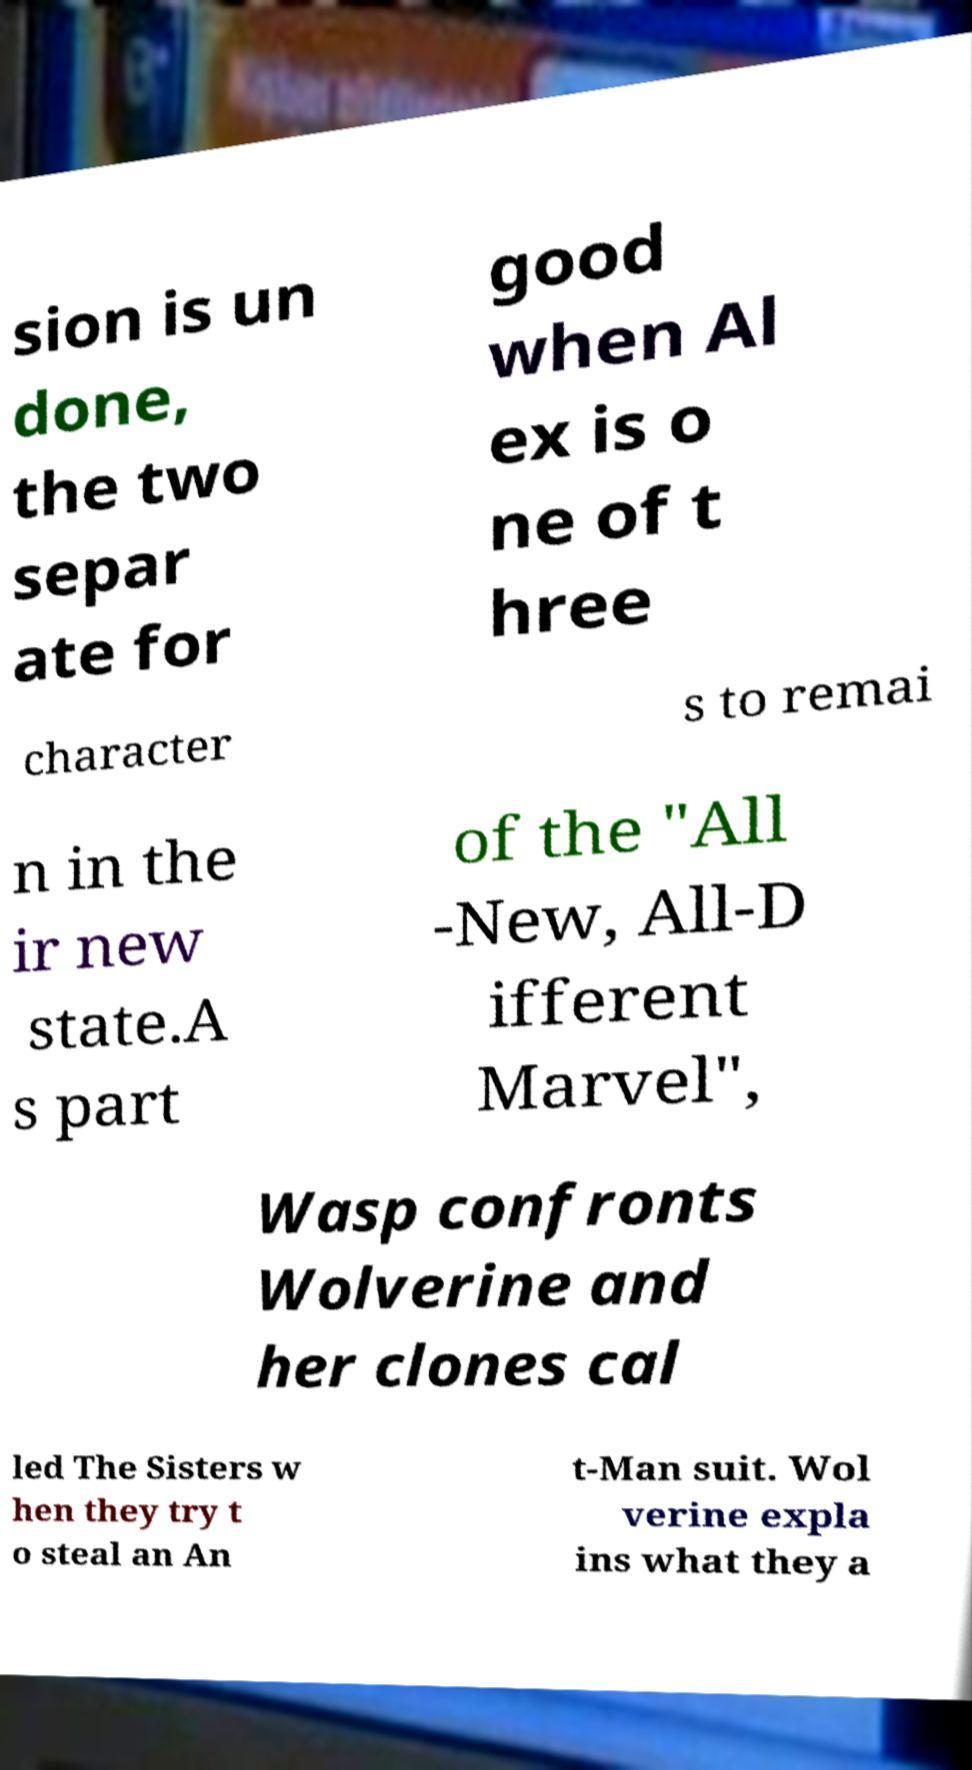Can you read and provide the text displayed in the image?This photo seems to have some interesting text. Can you extract and type it out for me? sion is un done, the two separ ate for good when Al ex is o ne of t hree character s to remai n in the ir new state.A s part of the "All -New, All-D ifferent Marvel", Wasp confronts Wolverine and her clones cal led The Sisters w hen they try t o steal an An t-Man suit. Wol verine expla ins what they a 